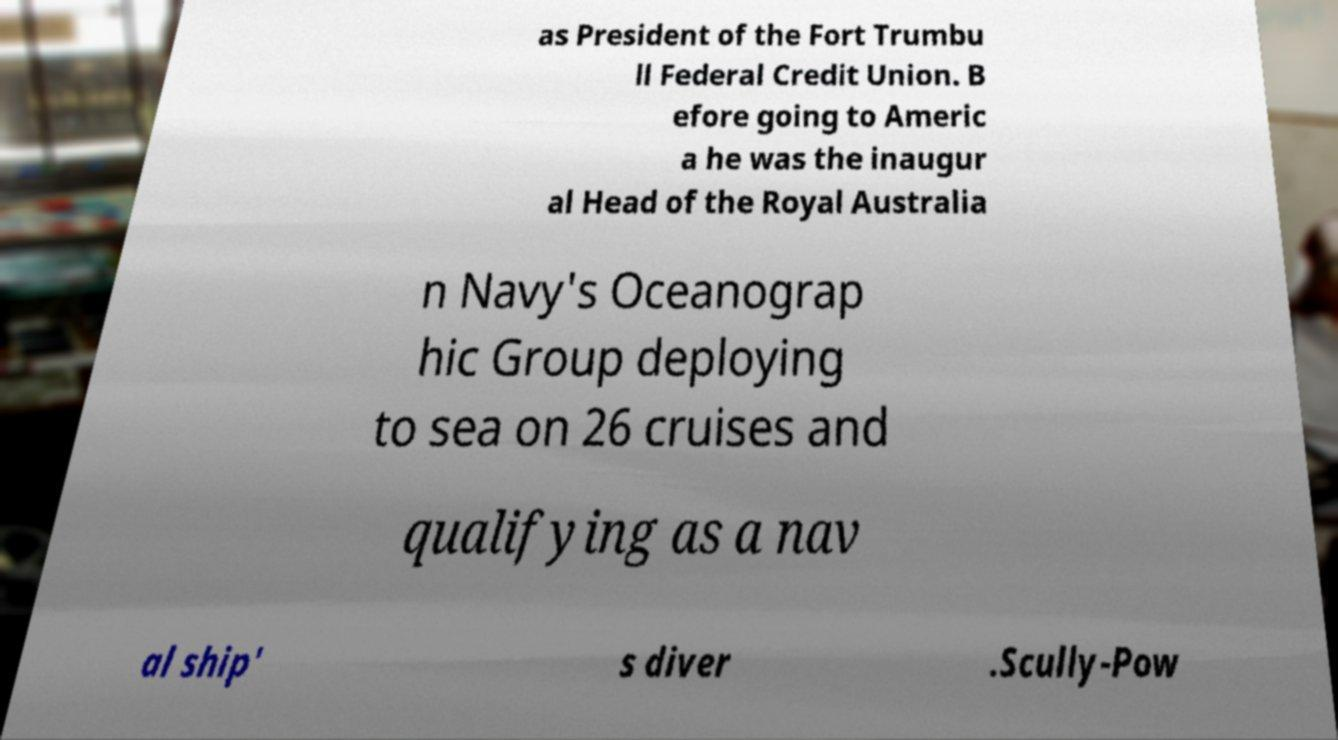Can you read and provide the text displayed in the image?This photo seems to have some interesting text. Can you extract and type it out for me? as President of the Fort Trumbu ll Federal Credit Union. B efore going to Americ a he was the inaugur al Head of the Royal Australia n Navy's Oceanograp hic Group deploying to sea on 26 cruises and qualifying as a nav al ship' s diver .Scully-Pow 